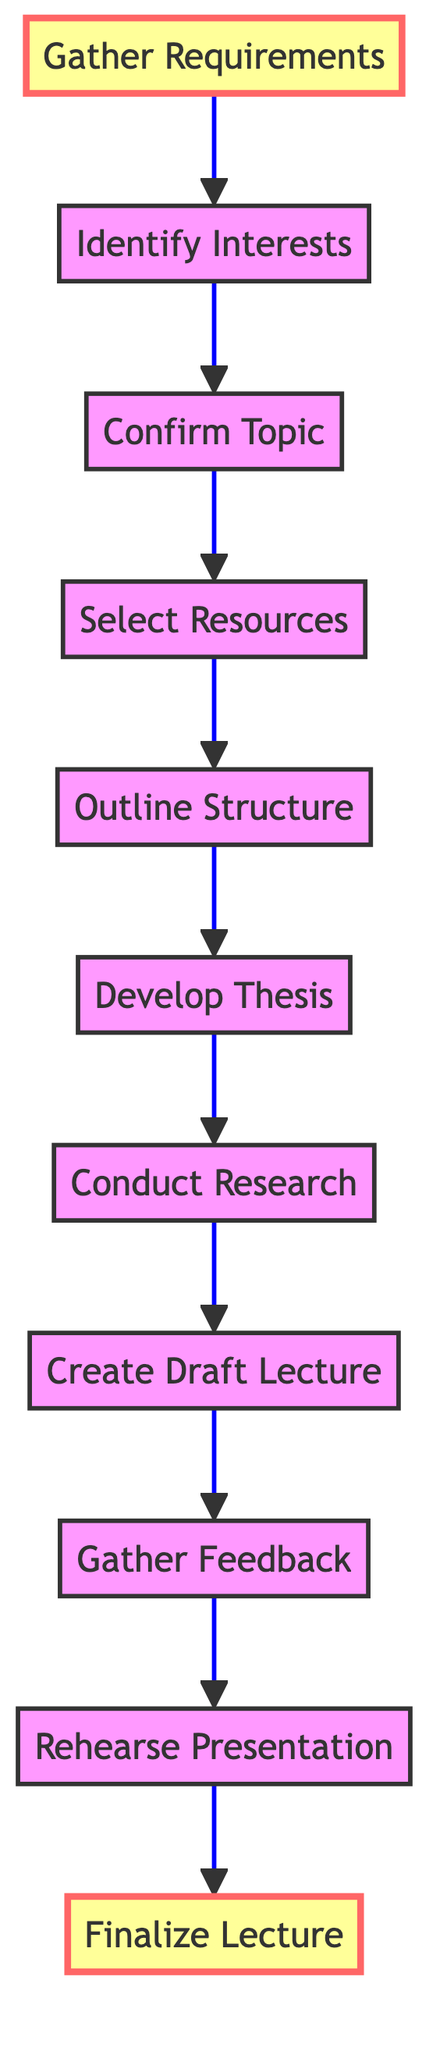What is the first step in developing an art history lecture? The first step in the flowchart is "Gather Requirements," which is indicated as the starting point before any further actions take place.
Answer: Gather Requirements How many total steps are involved in the lecture development process? Counting each step listed in the diagram, there are a total of 11 steps from "Gather Requirements" to "Finalize Lecture."
Answer: 11 Which step comes after "Gather Feedback"? "Rehearse Presentation" follows "Gather Feedback," according to the sequence outlined in the diagram connecting the steps.
Answer: Rehearse Presentation What task is associated with the "Conduct Research" step? The task associated with "Conduct Research" is to "Utilize academic databases, libraries, and digital resources to gather in-depth information on the selected topic."
Answer: Conduct detailed research What is the last step before finalizing the lecture? The last step before "Finalize Lecture" is "Rehearse Presentation," which prepares the lecturer for the final presentation.
Answer: Rehearse Presentation Which two steps are highlighted in the flowchart? The highlighted steps in the flowchart are "Gather Requirements" and "Finalize Lecture," indicated with a distinct fill color.
Answer: Gather Requirements, Finalize Lecture What is the main purpose of the "Develop Thesis" step? The purpose of the "Develop Thesis" step is to "Formulate the key argument or thesis that will drive the lecture, ensuring it is supported by research."
Answer: Develop the central thesis or argument How does the step "Select Resources" connect with "Outline Structure"? "Select Resources" leads directly to "Outline Structure" as the next step, showing the progression from resource selection to organizing those resources into a structured format.
Answer: Select Resources → Outline Structure What is the final task to be completed before delivering the lecture? The final task before delivering the lecture is to "Finalize the lecture slides and notes," ensuring everything is ready for presentation.
Answer: Finalize the lecture slides and notes 